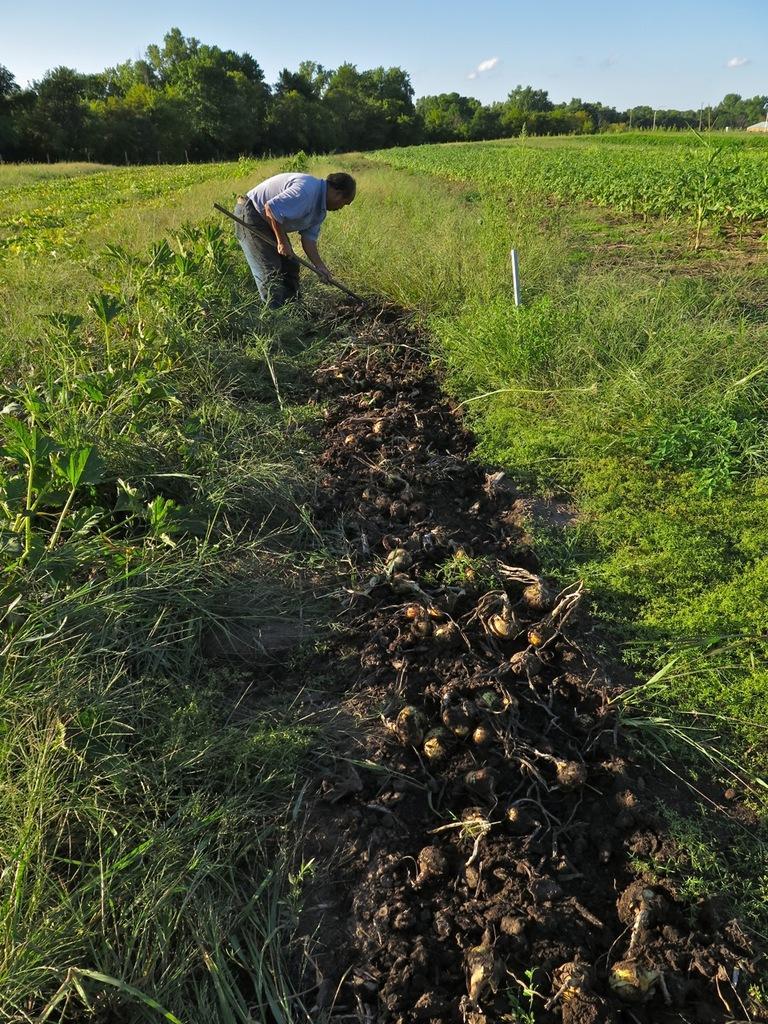In one or two sentences, can you explain what this image depicts? In this picture there is a man at the top side of the image, he is digging the floor and there is greenery around the area of the image. 